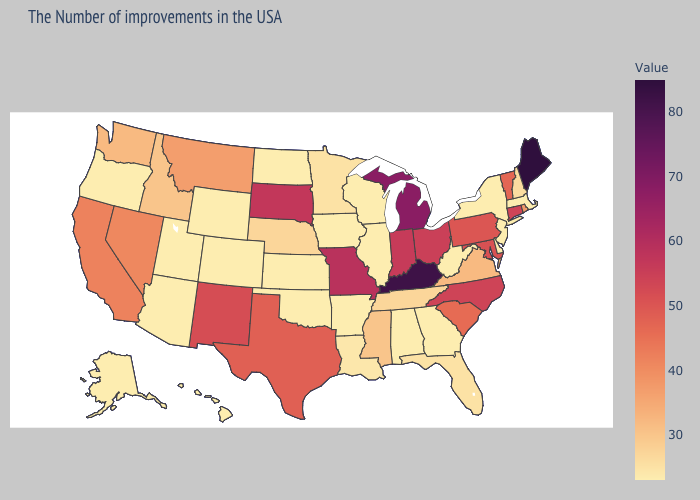Does Connecticut have a lower value than Maine?
Quick response, please. Yes. Which states have the lowest value in the West?
Answer briefly. Wyoming, Colorado, Utah, Arizona, Oregon, Alaska, Hawaii. Which states have the highest value in the USA?
Answer briefly. Maine. 